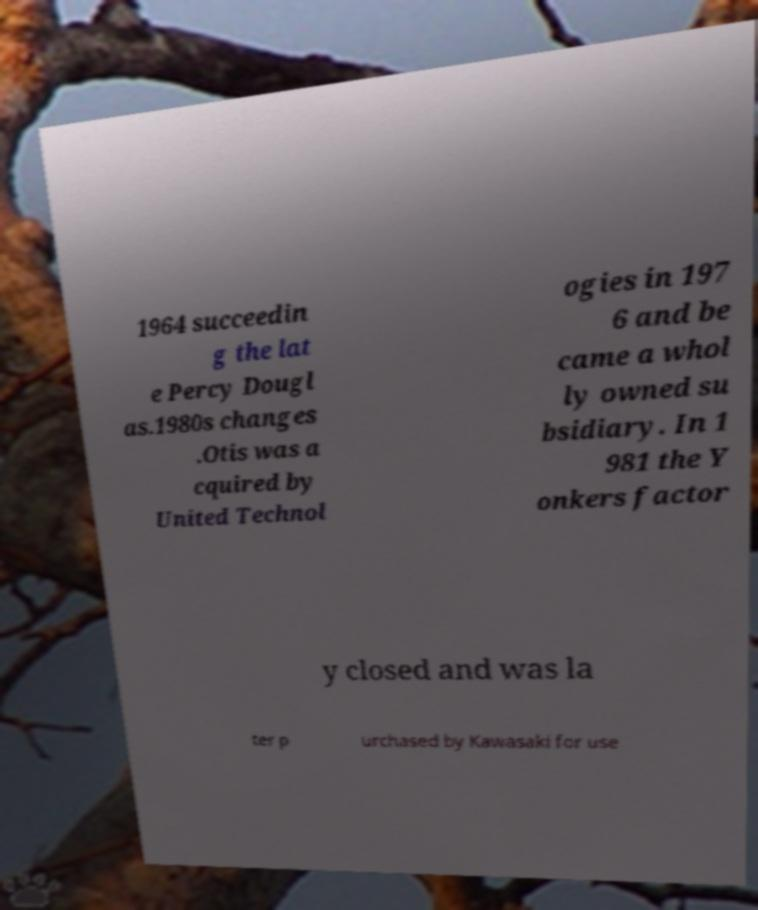For documentation purposes, I need the text within this image transcribed. Could you provide that? 1964 succeedin g the lat e Percy Dougl as.1980s changes .Otis was a cquired by United Technol ogies in 197 6 and be came a whol ly owned su bsidiary. In 1 981 the Y onkers factor y closed and was la ter p urchased by Kawasaki for use 